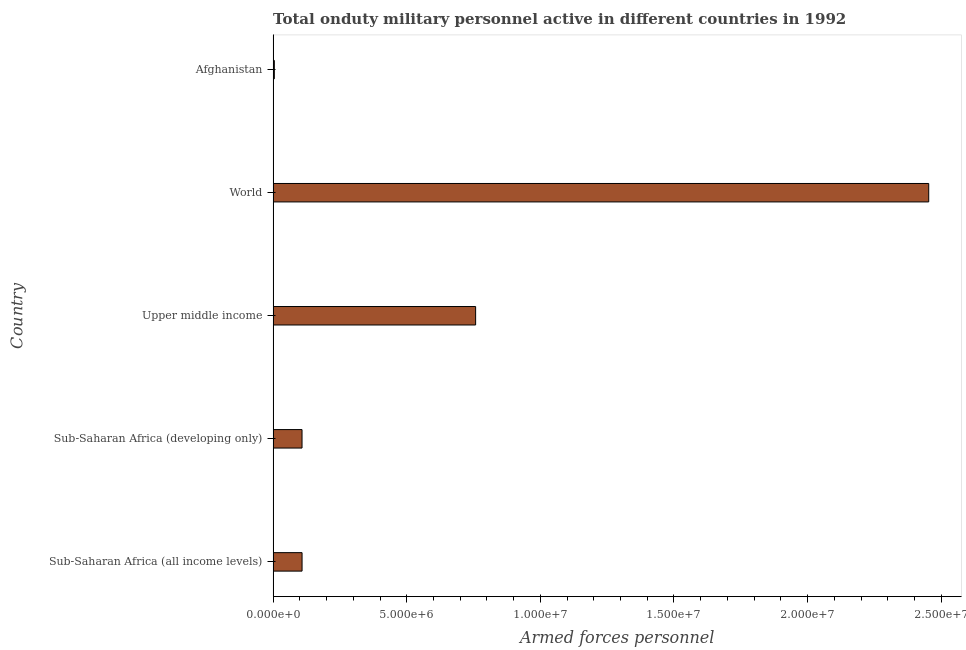What is the title of the graph?
Provide a short and direct response. Total onduty military personnel active in different countries in 1992. What is the label or title of the X-axis?
Keep it short and to the point. Armed forces personnel. What is the number of armed forces personnel in Sub-Saharan Africa (developing only)?
Your answer should be very brief. 1.08e+06. Across all countries, what is the maximum number of armed forces personnel?
Your response must be concise. 2.45e+07. Across all countries, what is the minimum number of armed forces personnel?
Offer a terse response. 4.50e+04. In which country was the number of armed forces personnel minimum?
Your response must be concise. Afghanistan. What is the sum of the number of armed forces personnel?
Ensure brevity in your answer.  3.43e+07. What is the difference between the number of armed forces personnel in Afghanistan and Sub-Saharan Africa (developing only)?
Give a very brief answer. -1.04e+06. What is the average number of armed forces personnel per country?
Your response must be concise. 6.86e+06. What is the median number of armed forces personnel?
Keep it short and to the point. 1.08e+06. What is the ratio of the number of armed forces personnel in Afghanistan to that in World?
Keep it short and to the point. 0. Is the number of armed forces personnel in Sub-Saharan Africa (all income levels) less than that in World?
Ensure brevity in your answer.  Yes. What is the difference between the highest and the second highest number of armed forces personnel?
Ensure brevity in your answer.  1.70e+07. What is the difference between the highest and the lowest number of armed forces personnel?
Give a very brief answer. 2.45e+07. How many bars are there?
Give a very brief answer. 5. How many countries are there in the graph?
Provide a succinct answer. 5. What is the Armed forces personnel in Sub-Saharan Africa (all income levels)?
Offer a terse response. 1.08e+06. What is the Armed forces personnel of Sub-Saharan Africa (developing only)?
Your answer should be compact. 1.08e+06. What is the Armed forces personnel of Upper middle income?
Offer a very short reply. 7.58e+06. What is the Armed forces personnel in World?
Your answer should be compact. 2.45e+07. What is the Armed forces personnel of Afghanistan?
Make the answer very short. 4.50e+04. What is the difference between the Armed forces personnel in Sub-Saharan Africa (all income levels) and Upper middle income?
Provide a succinct answer. -6.50e+06. What is the difference between the Armed forces personnel in Sub-Saharan Africa (all income levels) and World?
Your response must be concise. -2.34e+07. What is the difference between the Armed forces personnel in Sub-Saharan Africa (all income levels) and Afghanistan?
Your response must be concise. 1.04e+06. What is the difference between the Armed forces personnel in Sub-Saharan Africa (developing only) and Upper middle income?
Make the answer very short. -6.50e+06. What is the difference between the Armed forces personnel in Sub-Saharan Africa (developing only) and World?
Your answer should be compact. -2.35e+07. What is the difference between the Armed forces personnel in Sub-Saharan Africa (developing only) and Afghanistan?
Keep it short and to the point. 1.04e+06. What is the difference between the Armed forces personnel in Upper middle income and World?
Provide a succinct answer. -1.70e+07. What is the difference between the Armed forces personnel in Upper middle income and Afghanistan?
Your response must be concise. 7.53e+06. What is the difference between the Armed forces personnel in World and Afghanistan?
Your answer should be compact. 2.45e+07. What is the ratio of the Armed forces personnel in Sub-Saharan Africa (all income levels) to that in Upper middle income?
Make the answer very short. 0.14. What is the ratio of the Armed forces personnel in Sub-Saharan Africa (all income levels) to that in World?
Keep it short and to the point. 0.04. What is the ratio of the Armed forces personnel in Sub-Saharan Africa (all income levels) to that in Afghanistan?
Make the answer very short. 24.07. What is the ratio of the Armed forces personnel in Sub-Saharan Africa (developing only) to that in Upper middle income?
Your response must be concise. 0.14. What is the ratio of the Armed forces personnel in Sub-Saharan Africa (developing only) to that in World?
Provide a short and direct response. 0.04. What is the ratio of the Armed forces personnel in Sub-Saharan Africa (developing only) to that in Afghanistan?
Give a very brief answer. 24.04. What is the ratio of the Armed forces personnel in Upper middle income to that in World?
Your answer should be very brief. 0.31. What is the ratio of the Armed forces personnel in Upper middle income to that in Afghanistan?
Provide a succinct answer. 168.4. What is the ratio of the Armed forces personnel in World to that in Afghanistan?
Give a very brief answer. 545.18. 